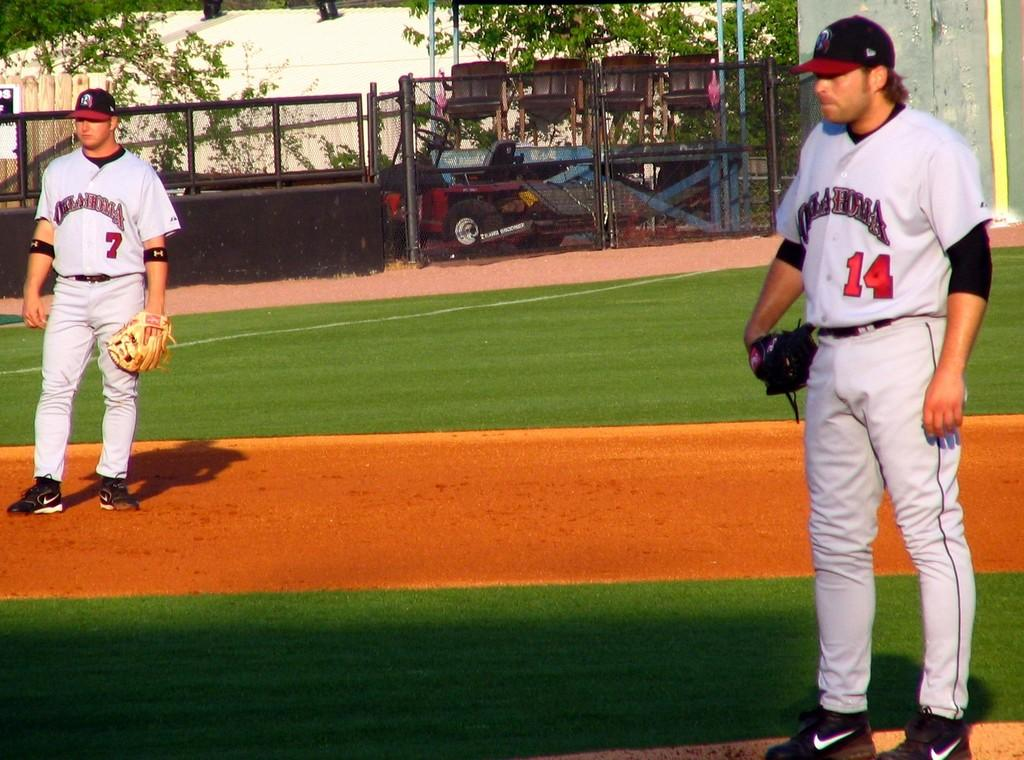<image>
Share a concise interpretation of the image provided. the number 14 that is on a jersey of a person 